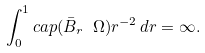<formula> <loc_0><loc_0><loc_500><loc_500>\int _ { 0 } ^ { 1 } c a p ( \bar { B } _ { r } \ \Omega ) r ^ { - 2 } \, d r = \infty .</formula> 